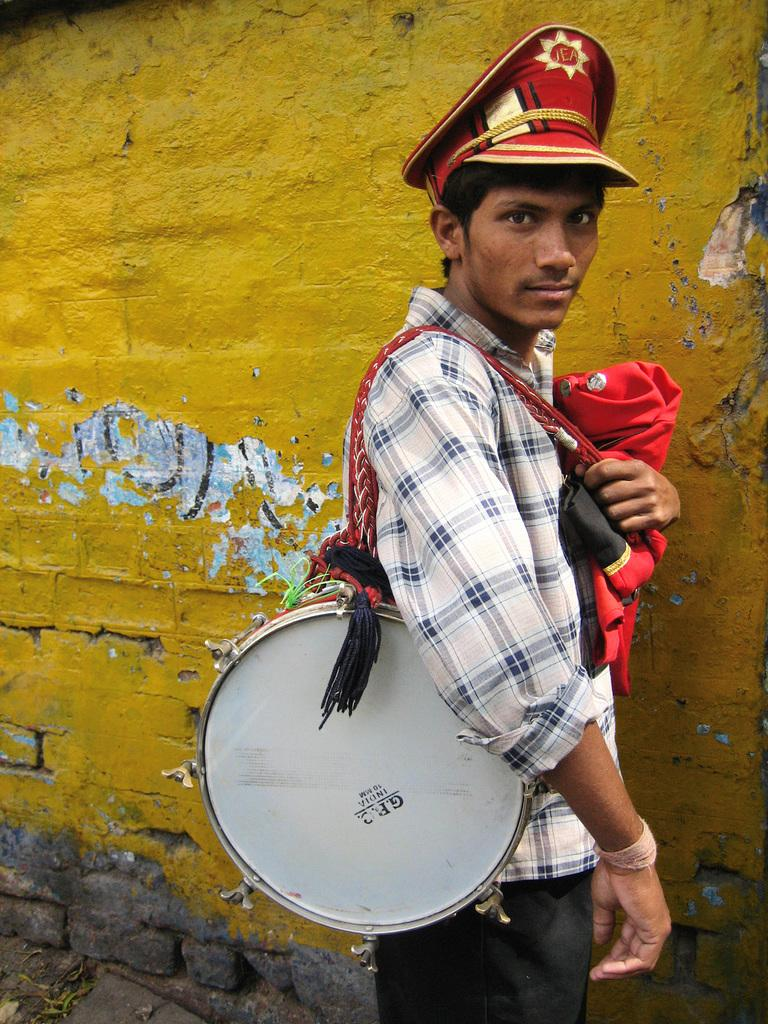What is the man in the picture doing? The man is holding a drum on his shoulders. What is the man wearing on his head? The man is wearing a hat. What is the man holding in his hand? The man is holding a dress in his hand. What can be seen in the background of the picture? There is a yellow colored wall in the background. What type of creature is sitting on the man's hat in the image? There is no creature sitting on the man's hat in the image. How many hands does the man have in the image? The man has two hands in the image, but the number of hands is not relevant to the image's content. 